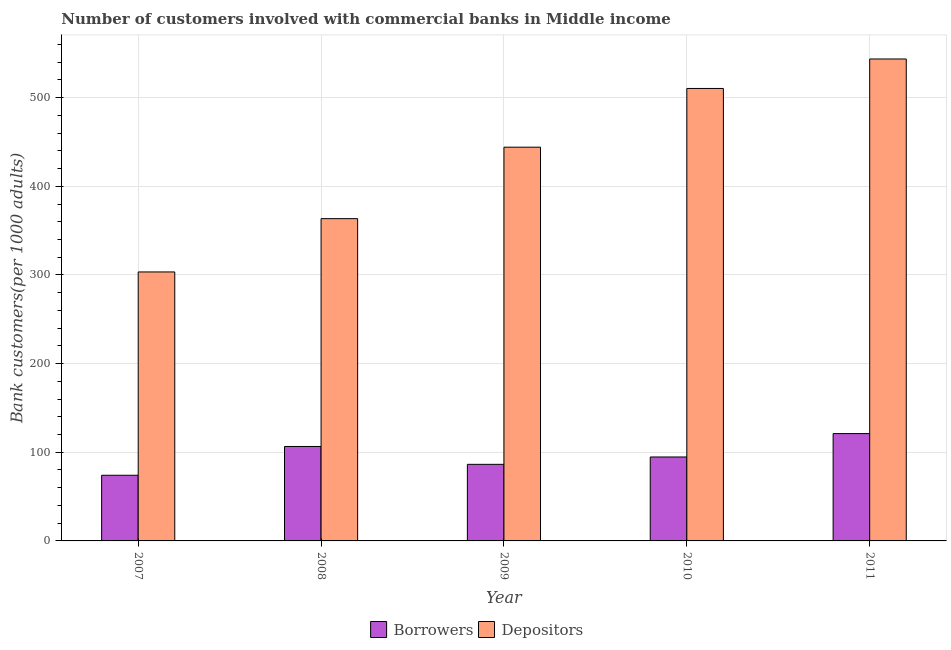How many different coloured bars are there?
Keep it short and to the point. 2. How many groups of bars are there?
Ensure brevity in your answer.  5. How many bars are there on the 3rd tick from the left?
Your answer should be very brief. 2. How many bars are there on the 4th tick from the right?
Ensure brevity in your answer.  2. What is the label of the 4th group of bars from the left?
Your response must be concise. 2010. In how many cases, is the number of bars for a given year not equal to the number of legend labels?
Keep it short and to the point. 0. What is the number of borrowers in 2008?
Make the answer very short. 106.53. Across all years, what is the maximum number of depositors?
Your answer should be compact. 543.59. Across all years, what is the minimum number of depositors?
Make the answer very short. 303.38. In which year was the number of depositors maximum?
Keep it short and to the point. 2011. What is the total number of depositors in the graph?
Ensure brevity in your answer.  2164.92. What is the difference between the number of borrowers in 2009 and that in 2010?
Give a very brief answer. -8.31. What is the difference between the number of borrowers in 2008 and the number of depositors in 2007?
Your response must be concise. 32.47. What is the average number of depositors per year?
Your answer should be very brief. 432.98. In the year 2010, what is the difference between the number of depositors and number of borrowers?
Keep it short and to the point. 0. What is the ratio of the number of borrowers in 2007 to that in 2011?
Give a very brief answer. 0.61. Is the difference between the number of borrowers in 2008 and 2011 greater than the difference between the number of depositors in 2008 and 2011?
Offer a very short reply. No. What is the difference between the highest and the second highest number of depositors?
Offer a very short reply. 33.25. What is the difference between the highest and the lowest number of borrowers?
Offer a very short reply. 47.02. Is the sum of the number of borrowers in 2007 and 2008 greater than the maximum number of depositors across all years?
Your response must be concise. Yes. What does the 1st bar from the left in 2009 represents?
Your answer should be very brief. Borrowers. What does the 1st bar from the right in 2010 represents?
Give a very brief answer. Depositors. Are all the bars in the graph horizontal?
Make the answer very short. No. Does the graph contain grids?
Keep it short and to the point. Yes. How many legend labels are there?
Offer a terse response. 2. What is the title of the graph?
Keep it short and to the point. Number of customers involved with commercial banks in Middle income. What is the label or title of the Y-axis?
Make the answer very short. Bank customers(per 1000 adults). What is the Bank customers(per 1000 adults) of Borrowers in 2007?
Give a very brief answer. 74.05. What is the Bank customers(per 1000 adults) of Depositors in 2007?
Make the answer very short. 303.38. What is the Bank customers(per 1000 adults) in Borrowers in 2008?
Your answer should be compact. 106.53. What is the Bank customers(per 1000 adults) of Depositors in 2008?
Provide a short and direct response. 363.5. What is the Bank customers(per 1000 adults) of Borrowers in 2009?
Your response must be concise. 86.38. What is the Bank customers(per 1000 adults) of Depositors in 2009?
Provide a succinct answer. 444.11. What is the Bank customers(per 1000 adults) in Borrowers in 2010?
Provide a succinct answer. 94.69. What is the Bank customers(per 1000 adults) in Depositors in 2010?
Keep it short and to the point. 510.34. What is the Bank customers(per 1000 adults) in Borrowers in 2011?
Your answer should be compact. 121.07. What is the Bank customers(per 1000 adults) in Depositors in 2011?
Make the answer very short. 543.59. Across all years, what is the maximum Bank customers(per 1000 adults) of Borrowers?
Offer a terse response. 121.07. Across all years, what is the maximum Bank customers(per 1000 adults) in Depositors?
Give a very brief answer. 543.59. Across all years, what is the minimum Bank customers(per 1000 adults) of Borrowers?
Make the answer very short. 74.05. Across all years, what is the minimum Bank customers(per 1000 adults) in Depositors?
Offer a very short reply. 303.38. What is the total Bank customers(per 1000 adults) in Borrowers in the graph?
Offer a very short reply. 482.72. What is the total Bank customers(per 1000 adults) in Depositors in the graph?
Your response must be concise. 2164.92. What is the difference between the Bank customers(per 1000 adults) in Borrowers in 2007 and that in 2008?
Offer a terse response. -32.47. What is the difference between the Bank customers(per 1000 adults) of Depositors in 2007 and that in 2008?
Keep it short and to the point. -60.11. What is the difference between the Bank customers(per 1000 adults) of Borrowers in 2007 and that in 2009?
Provide a short and direct response. -12.32. What is the difference between the Bank customers(per 1000 adults) of Depositors in 2007 and that in 2009?
Make the answer very short. -140.73. What is the difference between the Bank customers(per 1000 adults) of Borrowers in 2007 and that in 2010?
Make the answer very short. -20.64. What is the difference between the Bank customers(per 1000 adults) in Depositors in 2007 and that in 2010?
Give a very brief answer. -206.95. What is the difference between the Bank customers(per 1000 adults) in Borrowers in 2007 and that in 2011?
Offer a very short reply. -47.02. What is the difference between the Bank customers(per 1000 adults) of Depositors in 2007 and that in 2011?
Keep it short and to the point. -240.21. What is the difference between the Bank customers(per 1000 adults) of Borrowers in 2008 and that in 2009?
Your answer should be very brief. 20.15. What is the difference between the Bank customers(per 1000 adults) in Depositors in 2008 and that in 2009?
Keep it short and to the point. -80.61. What is the difference between the Bank customers(per 1000 adults) in Borrowers in 2008 and that in 2010?
Your answer should be very brief. 11.84. What is the difference between the Bank customers(per 1000 adults) of Depositors in 2008 and that in 2010?
Offer a very short reply. -146.84. What is the difference between the Bank customers(per 1000 adults) in Borrowers in 2008 and that in 2011?
Offer a terse response. -14.55. What is the difference between the Bank customers(per 1000 adults) in Depositors in 2008 and that in 2011?
Make the answer very short. -180.09. What is the difference between the Bank customers(per 1000 adults) of Borrowers in 2009 and that in 2010?
Keep it short and to the point. -8.31. What is the difference between the Bank customers(per 1000 adults) of Depositors in 2009 and that in 2010?
Provide a short and direct response. -66.23. What is the difference between the Bank customers(per 1000 adults) in Borrowers in 2009 and that in 2011?
Offer a very short reply. -34.7. What is the difference between the Bank customers(per 1000 adults) of Depositors in 2009 and that in 2011?
Offer a terse response. -99.48. What is the difference between the Bank customers(per 1000 adults) in Borrowers in 2010 and that in 2011?
Provide a succinct answer. -26.38. What is the difference between the Bank customers(per 1000 adults) of Depositors in 2010 and that in 2011?
Ensure brevity in your answer.  -33.25. What is the difference between the Bank customers(per 1000 adults) in Borrowers in 2007 and the Bank customers(per 1000 adults) in Depositors in 2008?
Offer a very short reply. -289.44. What is the difference between the Bank customers(per 1000 adults) in Borrowers in 2007 and the Bank customers(per 1000 adults) in Depositors in 2009?
Your answer should be compact. -370.06. What is the difference between the Bank customers(per 1000 adults) in Borrowers in 2007 and the Bank customers(per 1000 adults) in Depositors in 2010?
Ensure brevity in your answer.  -436.28. What is the difference between the Bank customers(per 1000 adults) in Borrowers in 2007 and the Bank customers(per 1000 adults) in Depositors in 2011?
Give a very brief answer. -469.54. What is the difference between the Bank customers(per 1000 adults) of Borrowers in 2008 and the Bank customers(per 1000 adults) of Depositors in 2009?
Your response must be concise. -337.58. What is the difference between the Bank customers(per 1000 adults) in Borrowers in 2008 and the Bank customers(per 1000 adults) in Depositors in 2010?
Offer a terse response. -403.81. What is the difference between the Bank customers(per 1000 adults) of Borrowers in 2008 and the Bank customers(per 1000 adults) of Depositors in 2011?
Offer a terse response. -437.06. What is the difference between the Bank customers(per 1000 adults) of Borrowers in 2009 and the Bank customers(per 1000 adults) of Depositors in 2010?
Provide a succinct answer. -423.96. What is the difference between the Bank customers(per 1000 adults) in Borrowers in 2009 and the Bank customers(per 1000 adults) in Depositors in 2011?
Your answer should be very brief. -457.22. What is the difference between the Bank customers(per 1000 adults) of Borrowers in 2010 and the Bank customers(per 1000 adults) of Depositors in 2011?
Your answer should be compact. -448.9. What is the average Bank customers(per 1000 adults) of Borrowers per year?
Offer a very short reply. 96.54. What is the average Bank customers(per 1000 adults) in Depositors per year?
Provide a succinct answer. 432.98. In the year 2007, what is the difference between the Bank customers(per 1000 adults) of Borrowers and Bank customers(per 1000 adults) of Depositors?
Provide a short and direct response. -229.33. In the year 2008, what is the difference between the Bank customers(per 1000 adults) in Borrowers and Bank customers(per 1000 adults) in Depositors?
Your response must be concise. -256.97. In the year 2009, what is the difference between the Bank customers(per 1000 adults) in Borrowers and Bank customers(per 1000 adults) in Depositors?
Your response must be concise. -357.74. In the year 2010, what is the difference between the Bank customers(per 1000 adults) in Borrowers and Bank customers(per 1000 adults) in Depositors?
Keep it short and to the point. -415.65. In the year 2011, what is the difference between the Bank customers(per 1000 adults) in Borrowers and Bank customers(per 1000 adults) in Depositors?
Keep it short and to the point. -422.52. What is the ratio of the Bank customers(per 1000 adults) of Borrowers in 2007 to that in 2008?
Offer a terse response. 0.7. What is the ratio of the Bank customers(per 1000 adults) of Depositors in 2007 to that in 2008?
Offer a very short reply. 0.83. What is the ratio of the Bank customers(per 1000 adults) in Borrowers in 2007 to that in 2009?
Provide a succinct answer. 0.86. What is the ratio of the Bank customers(per 1000 adults) in Depositors in 2007 to that in 2009?
Give a very brief answer. 0.68. What is the ratio of the Bank customers(per 1000 adults) in Borrowers in 2007 to that in 2010?
Ensure brevity in your answer.  0.78. What is the ratio of the Bank customers(per 1000 adults) of Depositors in 2007 to that in 2010?
Make the answer very short. 0.59. What is the ratio of the Bank customers(per 1000 adults) in Borrowers in 2007 to that in 2011?
Provide a short and direct response. 0.61. What is the ratio of the Bank customers(per 1000 adults) of Depositors in 2007 to that in 2011?
Your answer should be very brief. 0.56. What is the ratio of the Bank customers(per 1000 adults) of Borrowers in 2008 to that in 2009?
Give a very brief answer. 1.23. What is the ratio of the Bank customers(per 1000 adults) of Depositors in 2008 to that in 2009?
Your answer should be very brief. 0.82. What is the ratio of the Bank customers(per 1000 adults) in Depositors in 2008 to that in 2010?
Give a very brief answer. 0.71. What is the ratio of the Bank customers(per 1000 adults) of Borrowers in 2008 to that in 2011?
Provide a succinct answer. 0.88. What is the ratio of the Bank customers(per 1000 adults) in Depositors in 2008 to that in 2011?
Your answer should be very brief. 0.67. What is the ratio of the Bank customers(per 1000 adults) of Borrowers in 2009 to that in 2010?
Give a very brief answer. 0.91. What is the ratio of the Bank customers(per 1000 adults) in Depositors in 2009 to that in 2010?
Your answer should be very brief. 0.87. What is the ratio of the Bank customers(per 1000 adults) of Borrowers in 2009 to that in 2011?
Ensure brevity in your answer.  0.71. What is the ratio of the Bank customers(per 1000 adults) in Depositors in 2009 to that in 2011?
Your answer should be compact. 0.82. What is the ratio of the Bank customers(per 1000 adults) of Borrowers in 2010 to that in 2011?
Make the answer very short. 0.78. What is the ratio of the Bank customers(per 1000 adults) of Depositors in 2010 to that in 2011?
Your answer should be compact. 0.94. What is the difference between the highest and the second highest Bank customers(per 1000 adults) of Borrowers?
Offer a terse response. 14.55. What is the difference between the highest and the second highest Bank customers(per 1000 adults) in Depositors?
Offer a very short reply. 33.25. What is the difference between the highest and the lowest Bank customers(per 1000 adults) of Borrowers?
Offer a terse response. 47.02. What is the difference between the highest and the lowest Bank customers(per 1000 adults) of Depositors?
Provide a short and direct response. 240.21. 